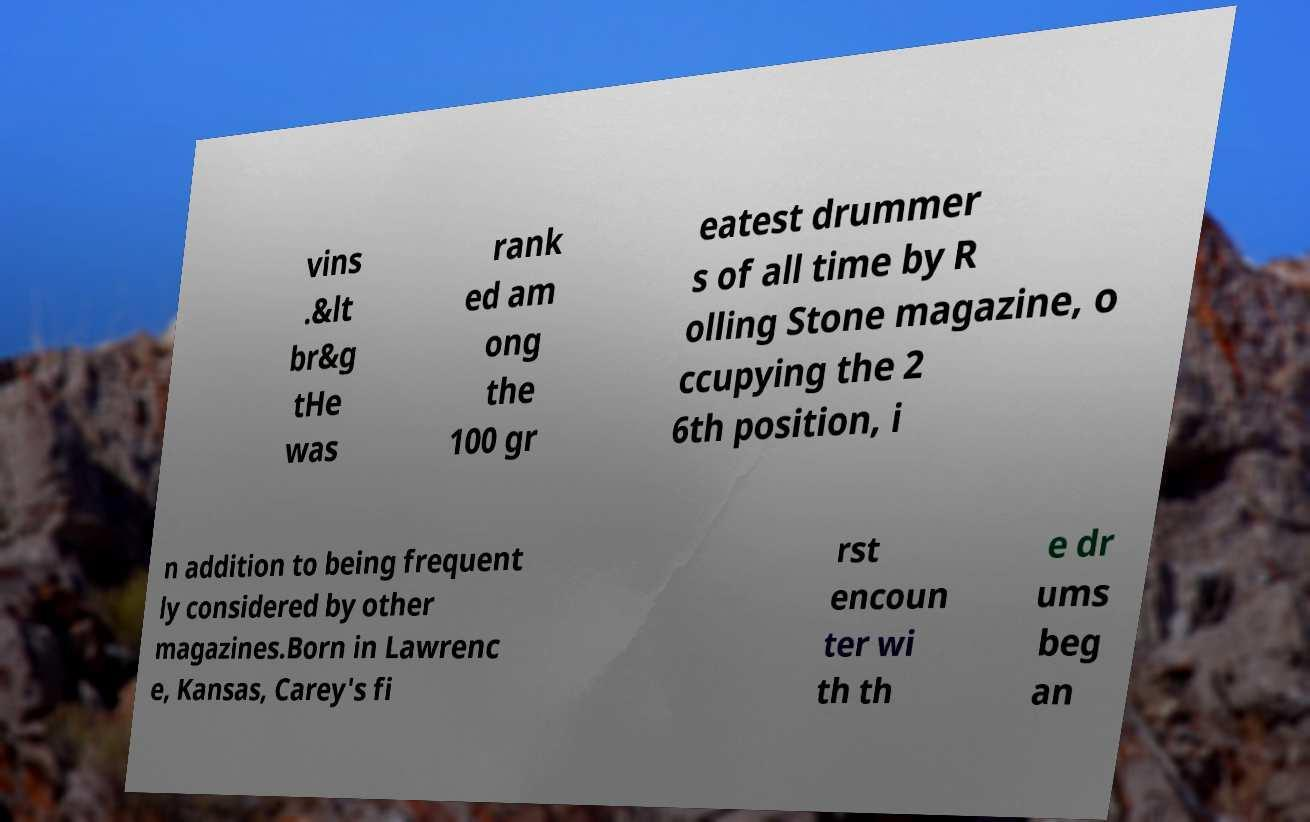For documentation purposes, I need the text within this image transcribed. Could you provide that? vins .&lt br&g tHe was rank ed am ong the 100 gr eatest drummer s of all time by R olling Stone magazine, o ccupying the 2 6th position, i n addition to being frequent ly considered by other magazines.Born in Lawrenc e, Kansas, Carey's fi rst encoun ter wi th th e dr ums beg an 